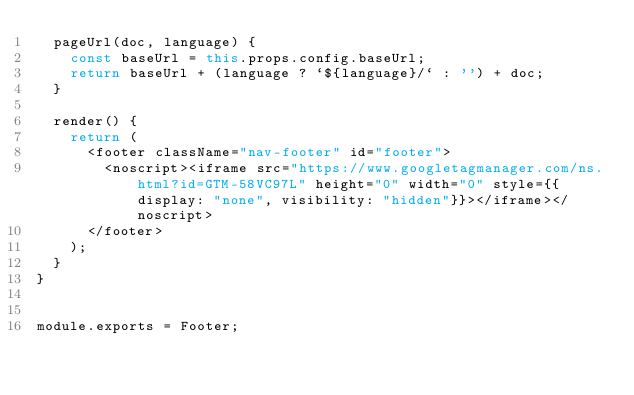<code> <loc_0><loc_0><loc_500><loc_500><_JavaScript_>  pageUrl(doc, language) {
    const baseUrl = this.props.config.baseUrl;
    return baseUrl + (language ? `${language}/` : '') + doc;
  }

  render() {
    return (
      <footer className="nav-footer" id="footer">
        <noscript><iframe src="https://www.googletagmanager.com/ns.html?id=GTM-58VC97L" height="0" width="0" style={{display: "none", visibility: "hidden"}}></iframe></noscript>
      </footer>
    );
  }
}


module.exports = Footer;
</code> 